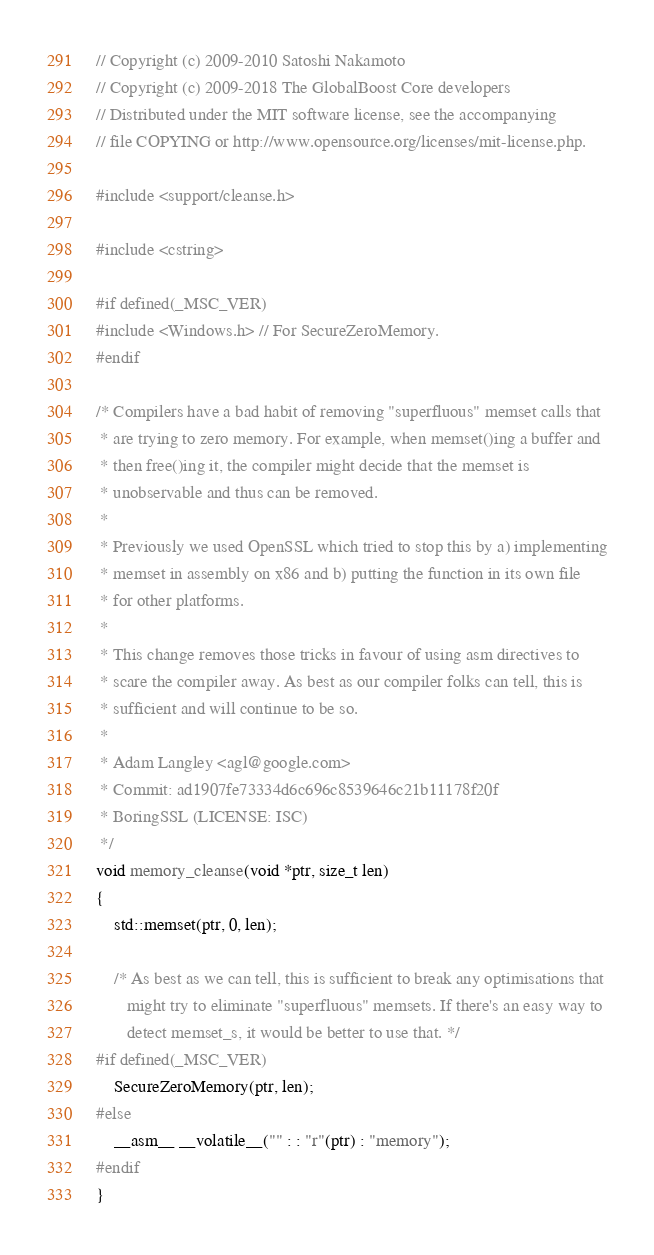<code> <loc_0><loc_0><loc_500><loc_500><_C++_>// Copyright (c) 2009-2010 Satoshi Nakamoto
// Copyright (c) 2009-2018 The GlobalBoost Core developers
// Distributed under the MIT software license, see the accompanying
// file COPYING or http://www.opensource.org/licenses/mit-license.php.

#include <support/cleanse.h>

#include <cstring>

#if defined(_MSC_VER)
#include <Windows.h> // For SecureZeroMemory.
#endif

/* Compilers have a bad habit of removing "superfluous" memset calls that
 * are trying to zero memory. For example, when memset()ing a buffer and
 * then free()ing it, the compiler might decide that the memset is
 * unobservable and thus can be removed.
 *
 * Previously we used OpenSSL which tried to stop this by a) implementing
 * memset in assembly on x86 and b) putting the function in its own file
 * for other platforms.
 *
 * This change removes those tricks in favour of using asm directives to
 * scare the compiler away. As best as our compiler folks can tell, this is
 * sufficient and will continue to be so.
 *
 * Adam Langley <agl@google.com>
 * Commit: ad1907fe73334d6c696c8539646c21b11178f20f
 * BoringSSL (LICENSE: ISC)
 */
void memory_cleanse(void *ptr, size_t len)
{
    std::memset(ptr, 0, len);

    /* As best as we can tell, this is sufficient to break any optimisations that
       might try to eliminate "superfluous" memsets. If there's an easy way to
       detect memset_s, it would be better to use that. */
#if defined(_MSC_VER)
    SecureZeroMemory(ptr, len);
#else
    __asm__ __volatile__("" : : "r"(ptr) : "memory");
#endif
}
</code> 